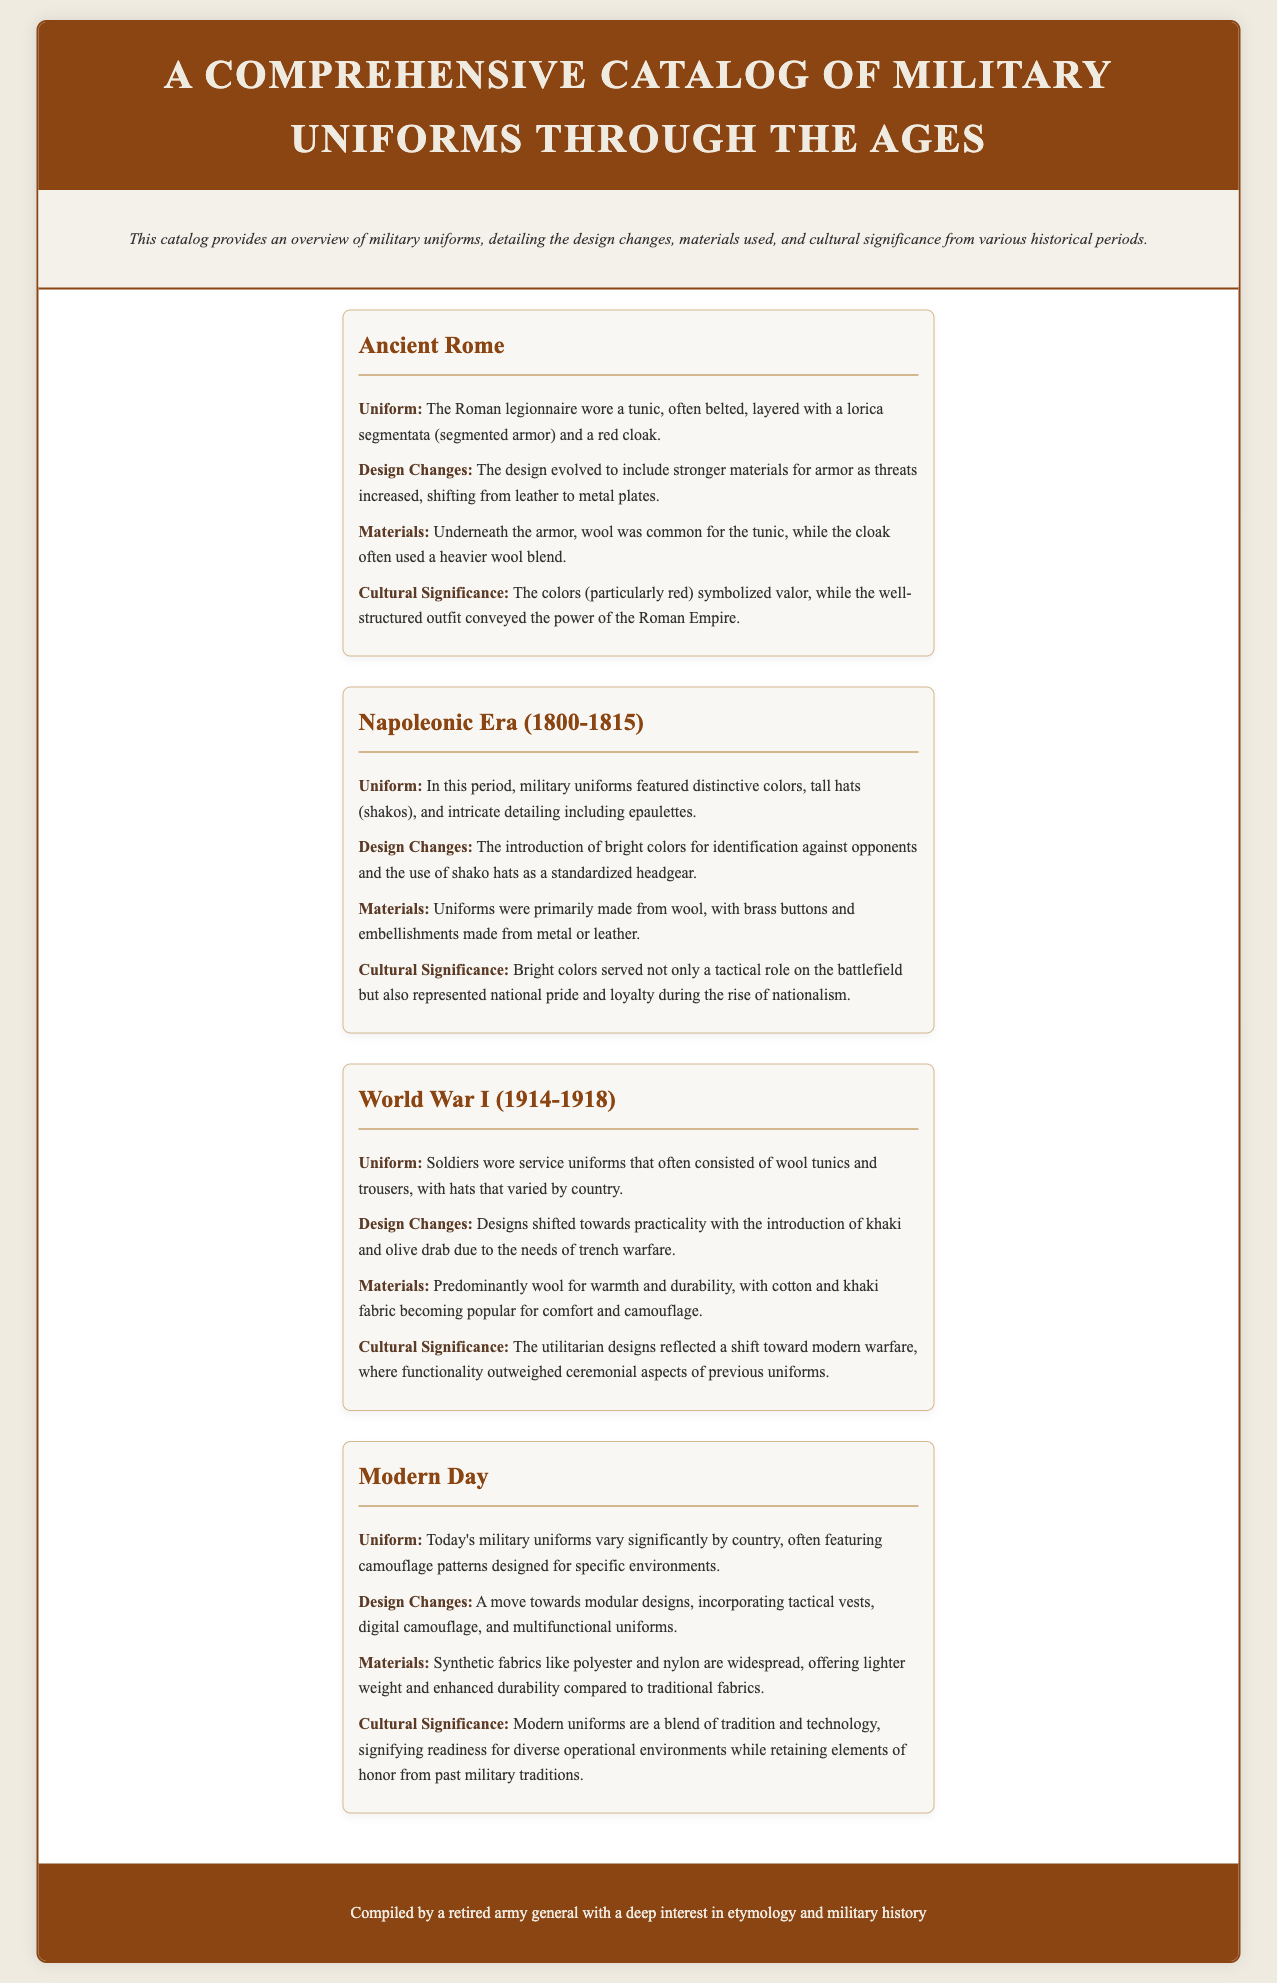What uniform did Roman legionnaires wear? The document states that Roman legionnaires wore a tunic layered with a lorica segmentata and a red cloak.
Answer: tunic, lorica segmentata, red cloak What material was primarily used for uniforms during World War I? The document notes that wool was predominantly used for warmth and durability in World War I uniforms.
Answer: wool Which era featured the introduction of shako hats? The Napoleon Era (1800-1815) is highlighted in the document as the period that introduced shako hats.
Answer: Napoleonic Era (1800-1815) What significant change occurred in the design of modern military uniforms? The document mentions a move towards modular designs in modern military uniforms.
Answer: modular designs What colors symbolized valor in Ancient Rome's military uniforms? The document states that the colors, particularly red, symbolized valor in Roman military uniforms.
Answer: red What unique feature defines modern military uniforms? The document describes modern uniforms as featuring camouflage patterns designed for specific environments.
Answer: camouflage patterns Which historical period did the design focus shift towards practicality? The document indicates that the design focus shifted towards practicality during World War I.
Answer: World War I What type of material is widely used in modern military uniforms? The document lists synthetic fabrics like polyester and nylon as widely used materials in modern military uniforms.
Answer: polyester and nylon 